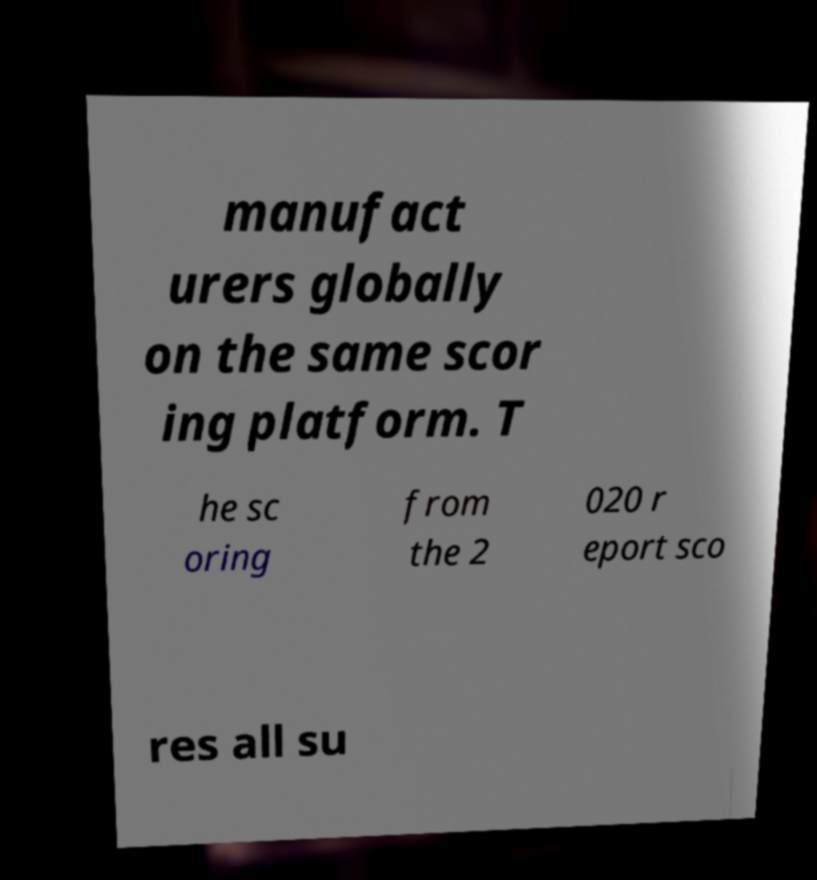I need the written content from this picture converted into text. Can you do that? manufact urers globally on the same scor ing platform. T he sc oring from the 2 020 r eport sco res all su 